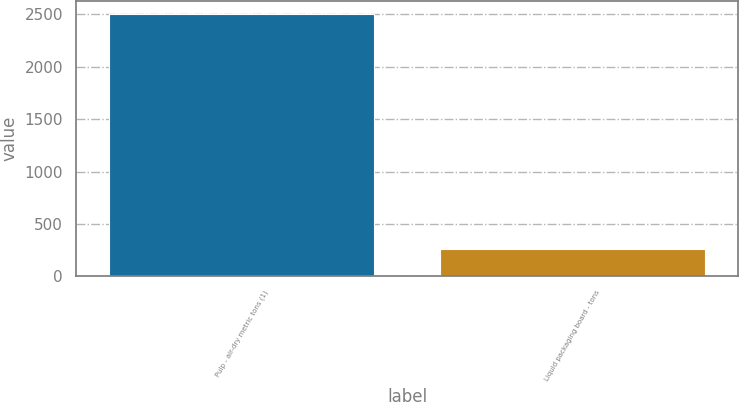<chart> <loc_0><loc_0><loc_500><loc_500><bar_chart><fcel>Pulp - air-dry metric tons (1)<fcel>Liquid packaging board - tons<nl><fcel>2502<fcel>258<nl></chart> 